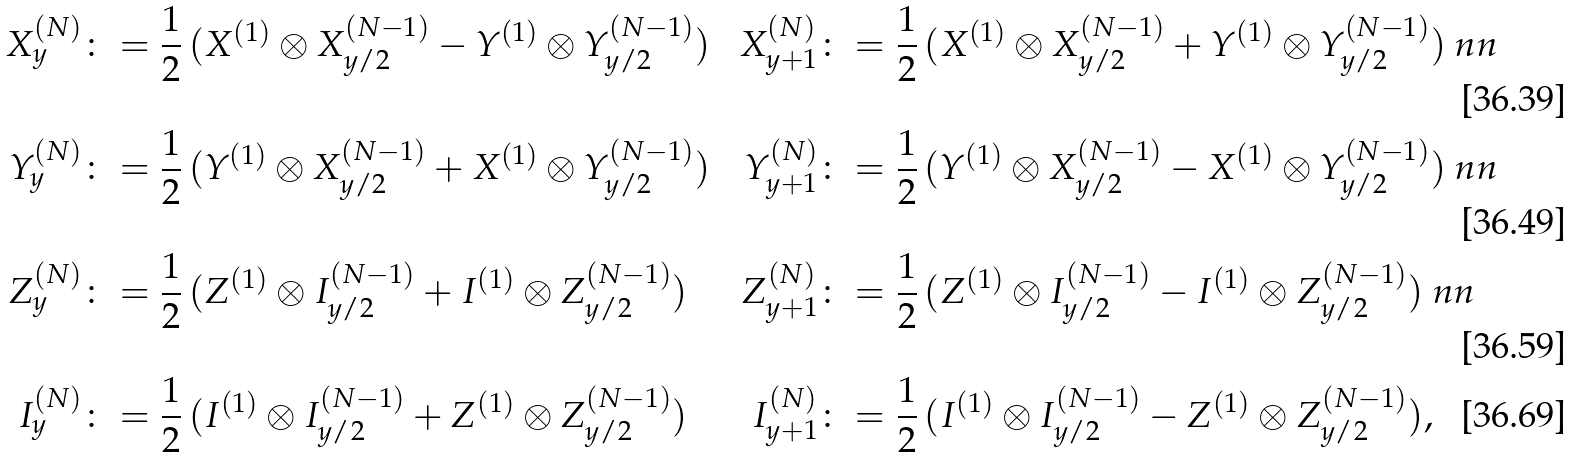Convert formula to latex. <formula><loc_0><loc_0><loc_500><loc_500>X ^ { ( N ) } _ { y } & \colon = \frac { 1 } { 2 } \, ( X ^ { ( 1 ) } \otimes X _ { y / 2 } ^ { ( N - 1 ) } - Y ^ { ( 1 ) } \otimes Y _ { y / 2 } ^ { ( N - 1 ) } ) & X ^ { ( N ) } _ { y + 1 } & \colon = \frac { 1 } { 2 } \, ( X ^ { ( 1 ) } \otimes X _ { y / 2 } ^ { ( N - 1 ) } + Y ^ { ( 1 ) } \otimes Y _ { y / 2 } ^ { ( N - 1 ) } ) \ n n \\ Y ^ { ( N ) } _ { y } & \colon = \frac { 1 } { 2 } \, ( Y ^ { ( 1 ) } \otimes X _ { y / 2 } ^ { ( N - 1 ) } + X ^ { ( 1 ) } \otimes Y _ { y / 2 } ^ { ( N - 1 ) } ) & Y ^ { ( N ) } _ { y + 1 } & \colon = \frac { 1 } { 2 } \, ( Y ^ { ( 1 ) } \otimes X _ { y / 2 } ^ { ( N - 1 ) } - X ^ { ( 1 ) } \otimes Y _ { y / 2 } ^ { ( N - 1 ) } ) \ n n \\ Z ^ { ( N ) } _ { y } & \colon = \frac { 1 } { 2 } \, ( Z ^ { ( 1 ) } \otimes I _ { y / 2 } ^ { ( N - 1 ) } + I ^ { ( 1 ) } \otimes Z _ { y / 2 } ^ { ( N - 1 ) } ) & Z ^ { ( N ) } _ { y + 1 } & \colon = \frac { 1 } { 2 } \, ( Z ^ { ( 1 ) } \otimes I _ { y / 2 } ^ { ( N - 1 ) } - I ^ { ( 1 ) } \otimes Z _ { y / 2 } ^ { ( N - 1 ) } ) \ n n \\ I ^ { ( N ) } _ { y } & \colon = \frac { 1 } { 2 } \, ( I ^ { ( 1 ) } \otimes I _ { y / 2 } ^ { ( N - 1 ) } + Z ^ { ( 1 ) } \otimes Z _ { y / 2 } ^ { ( N - 1 ) } ) & I ^ { ( N ) } _ { y + 1 } & \colon = \frac { 1 } { 2 } \, ( I ^ { ( 1 ) } \otimes I _ { y / 2 } ^ { ( N - 1 ) } - Z ^ { ( 1 ) } \otimes Z _ { y / 2 } ^ { ( N - 1 ) } ) ,</formula> 